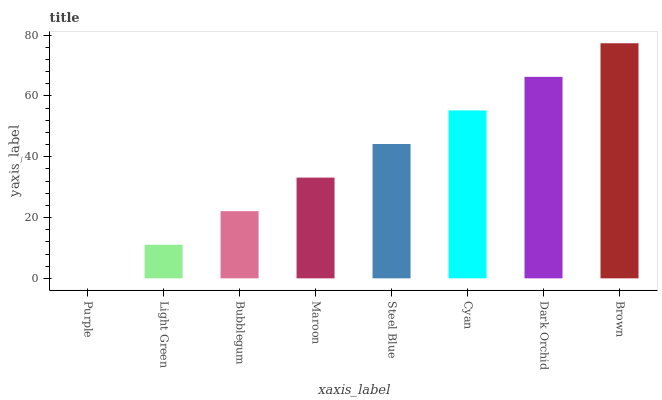Is Purple the minimum?
Answer yes or no. Yes. Is Brown the maximum?
Answer yes or no. Yes. Is Light Green the minimum?
Answer yes or no. No. Is Light Green the maximum?
Answer yes or no. No. Is Light Green greater than Purple?
Answer yes or no. Yes. Is Purple less than Light Green?
Answer yes or no. Yes. Is Purple greater than Light Green?
Answer yes or no. No. Is Light Green less than Purple?
Answer yes or no. No. Is Steel Blue the high median?
Answer yes or no. Yes. Is Maroon the low median?
Answer yes or no. Yes. Is Maroon the high median?
Answer yes or no. No. Is Cyan the low median?
Answer yes or no. No. 